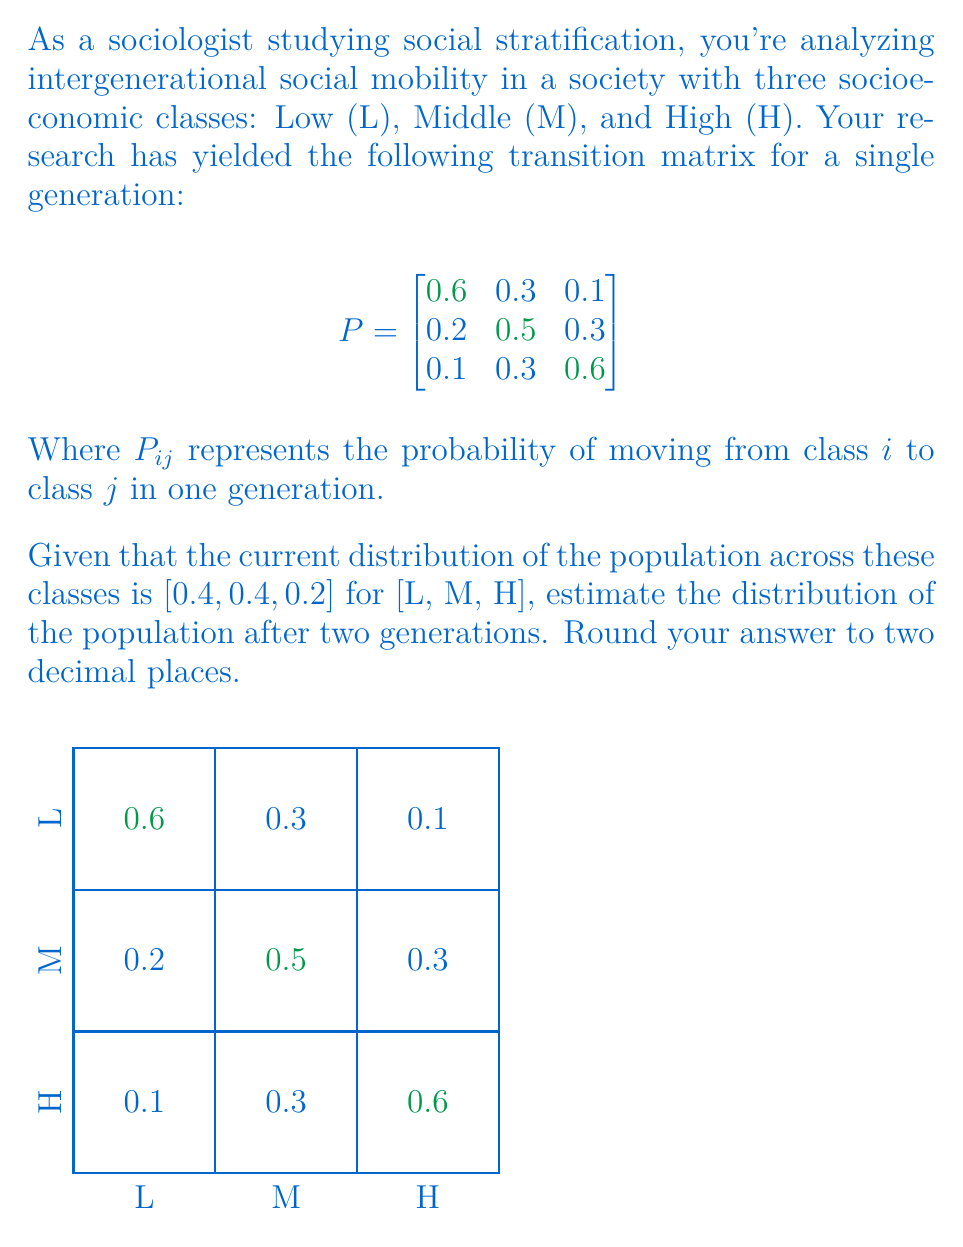Teach me how to tackle this problem. To solve this problem, we'll use the properties of Markov chains:

1) First, let's define our initial state vector:
   $v_0 = [0.4, 0.4, 0.2]$

2) To find the distribution after two generations, we need to multiply this vector by the transition matrix twice:
   $v_2 = v_0 \cdot P^2$

3) Let's calculate $P^2$:
   $$P^2 = P \cdot P = \begin{bmatrix}
   0.6 & 0.3 & 0.1 \\
   0.2 & 0.5 & 0.3 \\
   0.1 & 0.3 & 0.6
   \end{bmatrix} \cdot \begin{bmatrix}
   0.6 & 0.3 & 0.1 \\
   0.2 & 0.5 & 0.3 \\
   0.1 & 0.3 & 0.6
   \end{bmatrix}$$

4) Performing the matrix multiplication:
   $$P^2 = \begin{bmatrix}
   0.43 & 0.36 & 0.21 \\
   0.25 & 0.43 & 0.32 \\
   0.19 & 0.36 & 0.45
   \end{bmatrix}$$

5) Now, we multiply our initial state vector by $P^2$:
   $v_2 = [0.4, 0.4, 0.2] \cdot \begin{bmatrix}
   0.43 & 0.36 & 0.21 \\
   0.25 & 0.43 & 0.32 \\
   0.19 & 0.36 & 0.45
   \end{bmatrix}$

6) Performing this multiplication:
   $v_2 = [0.334, 0.388, 0.278]$

7) Rounding to two decimal places:
   $v_2 \approx [0.33, 0.39, 0.28]$

This result shows the estimated distribution of the population across the Low, Middle, and High socioeconomic classes after two generations.
Answer: [0.33, 0.39, 0.28] 